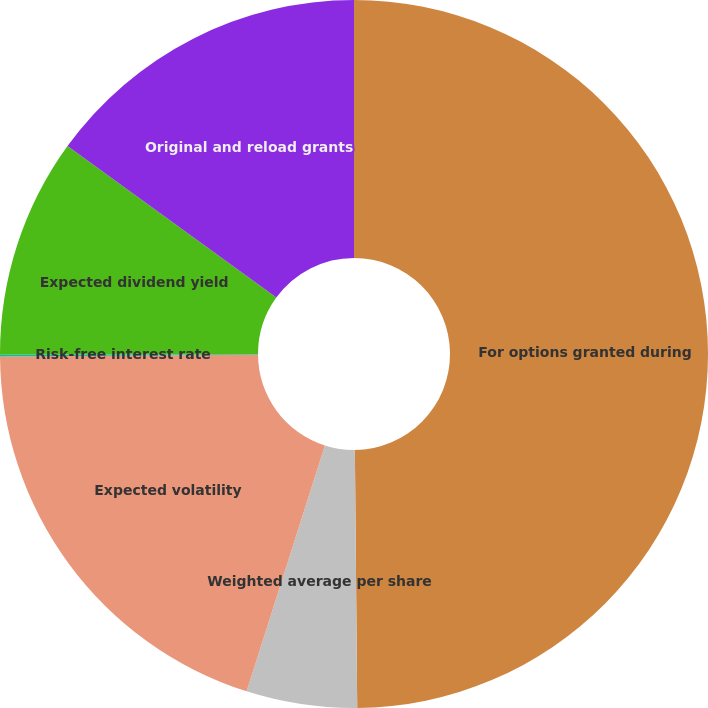<chart> <loc_0><loc_0><loc_500><loc_500><pie_chart><fcel>For options granted during<fcel>Weighted average per share<fcel>Expected volatility<fcel>Risk-free interest rate<fcel>Expected dividend yield<fcel>Original and reload grants<nl><fcel>49.86%<fcel>5.05%<fcel>19.99%<fcel>0.07%<fcel>10.03%<fcel>15.01%<nl></chart> 